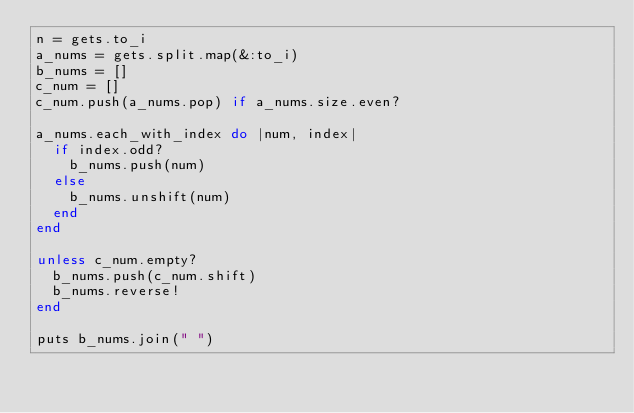<code> <loc_0><loc_0><loc_500><loc_500><_Ruby_>n = gets.to_i
a_nums = gets.split.map(&:to_i)
b_nums = []
c_num = []
c_num.push(a_nums.pop) if a_nums.size.even?

a_nums.each_with_index do |num, index|
  if index.odd?
    b_nums.push(num)
  else
    b_nums.unshift(num)
  end
end

unless c_num.empty?
  b_nums.push(c_num.shift)
  b_nums.reverse!
end

puts b_nums.join(" ")
</code> 